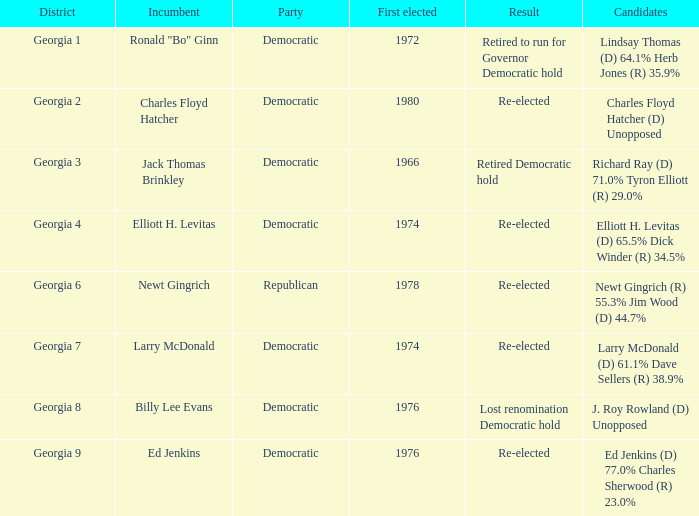Name the party for jack thomas brinkley Democratic. 